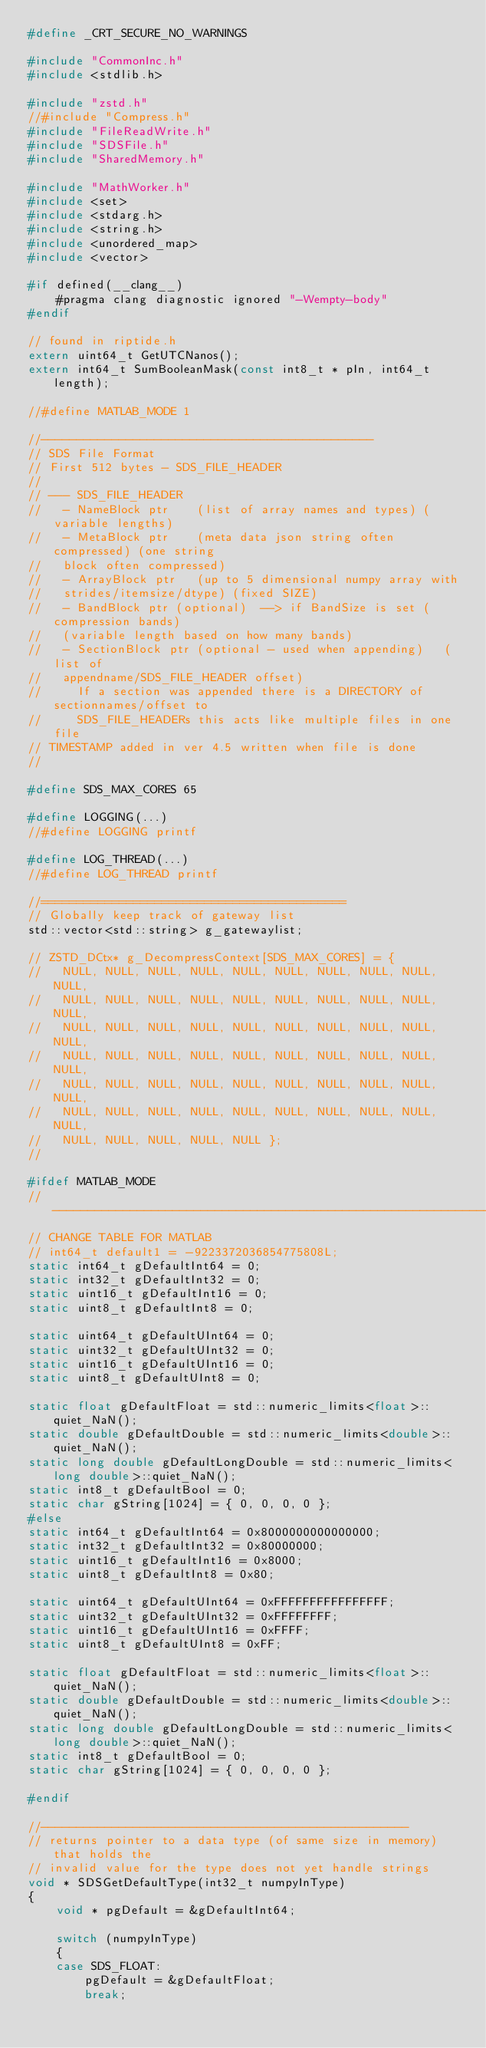Convert code to text. <code><loc_0><loc_0><loc_500><loc_500><_C++_>#define _CRT_SECURE_NO_WARNINGS

#include "CommonInc.h"
#include <stdlib.h>

#include "zstd.h"
//#include "Compress.h"
#include "FileReadWrite.h"
#include "SDSFile.h"
#include "SharedMemory.h"

#include "MathWorker.h"
#include <set>
#include <stdarg.h>
#include <string.h>
#include <unordered_map>
#include <vector>

#if defined(__clang__)
    #pragma clang diagnostic ignored "-Wempty-body"
#endif

// found in riptide.h
extern uint64_t GetUTCNanos();
extern int64_t SumBooleanMask(const int8_t * pIn, int64_t length);

//#define MATLAB_MODE 1

//-----------------------------------------------
// SDS File Format
// First 512 bytes - SDS_FILE_HEADER
//
// --- SDS_FILE_HEADER
//   - NameBlock ptr    (list of array names and types) (variable lengths)
//   - MetaBlock ptr    (meta data json string often compressed) (one string
//   block often compressed)
//   - ArrayBlock ptr   (up to 5 dimensional numpy array with
//   strides/itemsize/dtype) (fixed SIZE)
//   - BandBlock ptr (optional)  --> if BandSize is set (compression bands)
//   (variable length based on how many bands)
//   - SectionBlock ptr (optional - used when appending)   (list of
//   appendname/SDS_FILE_HEADER offset)
//     If a section was appended there is a DIRECTORY of sectionnames/offset to
//     SDS_FILE_HEADERs this acts like multiple files in one file
// TIMESTAMP added in ver 4.5 written when file is done
//

#define SDS_MAX_CORES 65

#define LOGGING(...)
//#define LOGGING printf

#define LOG_THREAD(...)
//#define LOG_THREAD printf

//===========================================
// Globally keep track of gateway list
std::vector<std::string> g_gatewaylist;

// ZSTD_DCtx* g_DecompressContext[SDS_MAX_CORES] = {
//   NULL, NULL, NULL, NULL, NULL, NULL, NULL, NULL, NULL, NULL,
//   NULL, NULL, NULL, NULL, NULL, NULL, NULL, NULL, NULL, NULL,
//   NULL, NULL, NULL, NULL, NULL, NULL, NULL, NULL, NULL, NULL,
//   NULL, NULL, NULL, NULL, NULL, NULL, NULL, NULL, NULL, NULL,
//   NULL, NULL, NULL, NULL, NULL, NULL, NULL, NULL, NULL, NULL,
//   NULL, NULL, NULL, NULL, NULL, NULL, NULL, NULL, NULL, NULL,
//   NULL, NULL, NULL, NULL, NULL };
//

#ifdef MATLAB_MODE
//-------------------------------------------------------------------------
// CHANGE TABLE FOR MATLAB
// int64_t default1 = -9223372036854775808L;
static int64_t gDefaultInt64 = 0;
static int32_t gDefaultInt32 = 0;
static uint16_t gDefaultInt16 = 0;
static uint8_t gDefaultInt8 = 0;

static uint64_t gDefaultUInt64 = 0;
static uint32_t gDefaultUInt32 = 0;
static uint16_t gDefaultUInt16 = 0;
static uint8_t gDefaultUInt8 = 0;

static float gDefaultFloat = std::numeric_limits<float>::quiet_NaN();
static double gDefaultDouble = std::numeric_limits<double>::quiet_NaN();
static long double gDefaultLongDouble = std::numeric_limits<long double>::quiet_NaN();
static int8_t gDefaultBool = 0;
static char gString[1024] = { 0, 0, 0, 0 };
#else
static int64_t gDefaultInt64 = 0x8000000000000000;
static int32_t gDefaultInt32 = 0x80000000;
static uint16_t gDefaultInt16 = 0x8000;
static uint8_t gDefaultInt8 = 0x80;

static uint64_t gDefaultUInt64 = 0xFFFFFFFFFFFFFFFF;
static uint32_t gDefaultUInt32 = 0xFFFFFFFF;
static uint16_t gDefaultUInt16 = 0xFFFF;
static uint8_t gDefaultUInt8 = 0xFF;

static float gDefaultFloat = std::numeric_limits<float>::quiet_NaN();
static double gDefaultDouble = std::numeric_limits<double>::quiet_NaN();
static long double gDefaultLongDouble = std::numeric_limits<long double>::quiet_NaN();
static int8_t gDefaultBool = 0;
static char gString[1024] = { 0, 0, 0, 0 };

#endif

//----------------------------------------------------
// returns pointer to a data type (of same size in memory) that holds the
// invalid value for the type does not yet handle strings
void * SDSGetDefaultType(int32_t numpyInType)
{
    void * pgDefault = &gDefaultInt64;

    switch (numpyInType)
    {
    case SDS_FLOAT:
        pgDefault = &gDefaultFloat;
        break;</code> 